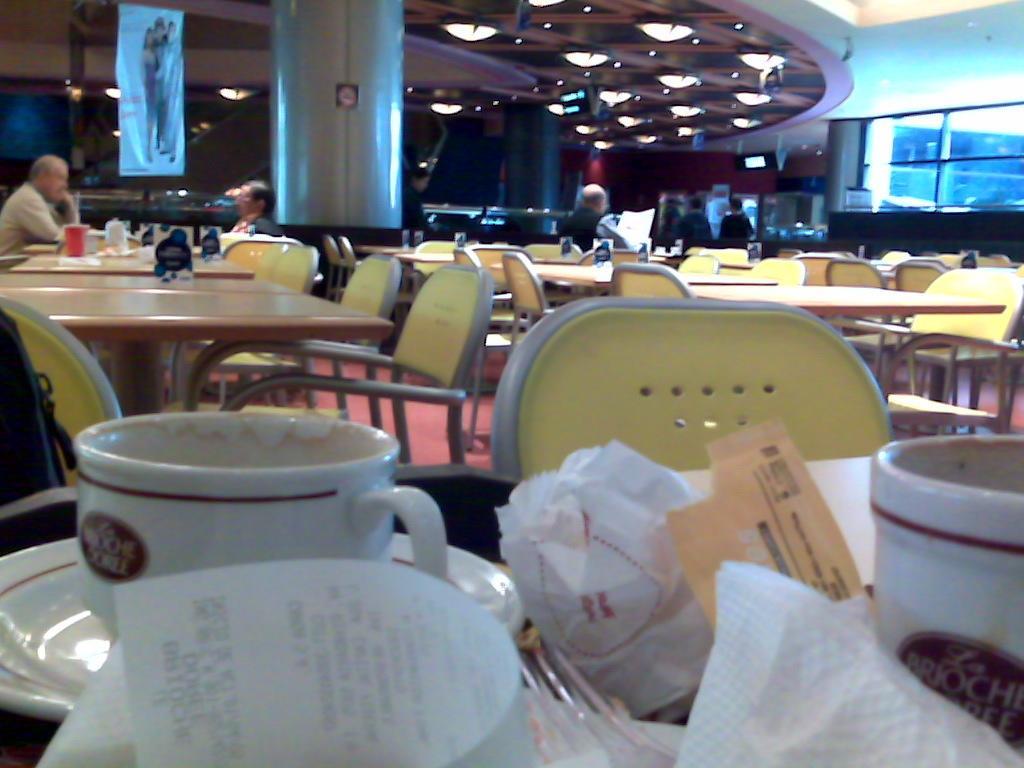Please provide a concise description of this image. In this image there are few chairs and tables. In the front we can see cup and saucer, papers. Two people sat at the left side of the image and few people at the middle of image. LIghts are fixed to the roof. Left top there is a banner hanged from the roof. 